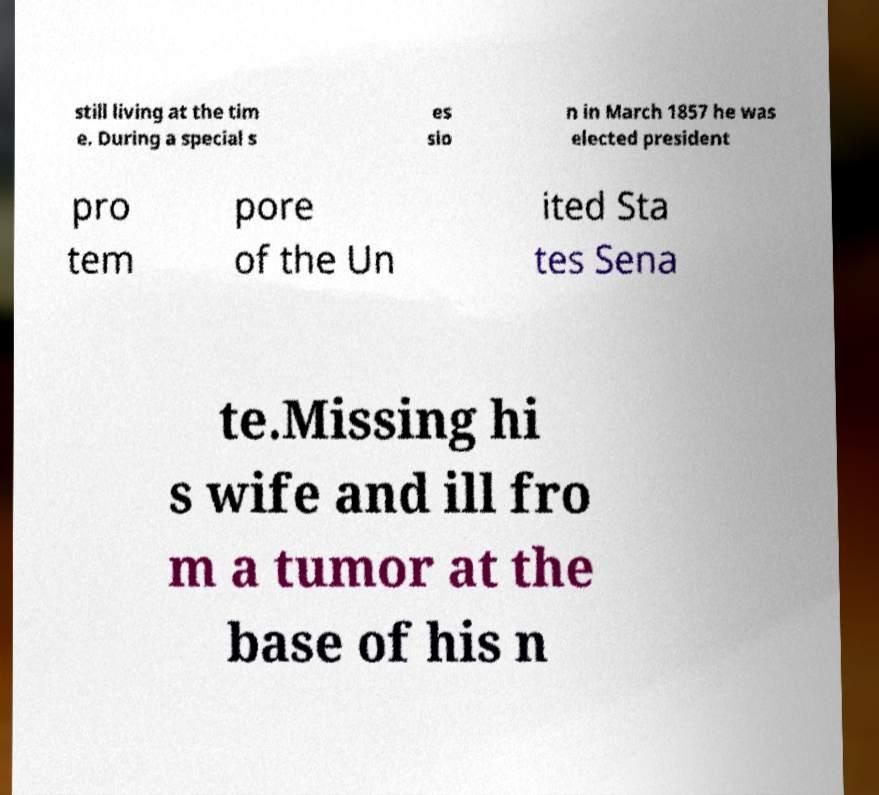There's text embedded in this image that I need extracted. Can you transcribe it verbatim? still living at the tim e. During a special s es sio n in March 1857 he was elected president pro tem pore of the Un ited Sta tes Sena te.Missing hi s wife and ill fro m a tumor at the base of his n 